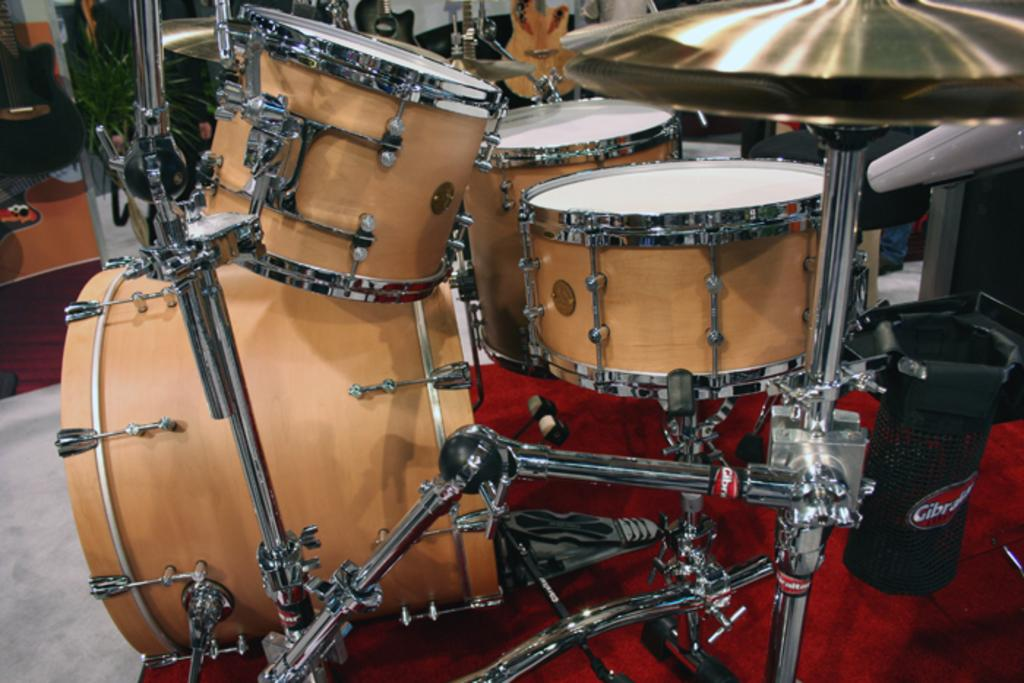What musical instruments are present in the image? There are drums, cymbals, and a guitar in the image. Where is the dustbin located in the image? The dustbin is on the right side of the image. What type of plant can be seen on the left side of the image? There is a house plant on the left side of the image. What other objects are on the left side of the image besides the guitar and house plant? There are other objects on the left side of the image, but their specific details are not mentioned in the provided facts. What type of beef is being prepared in the basin on the left side of the image? There is no beef or basin present in the image. How much salt is sprinkled on the guitar strings in the image? There is no salt or indication of salt usage in the image. 